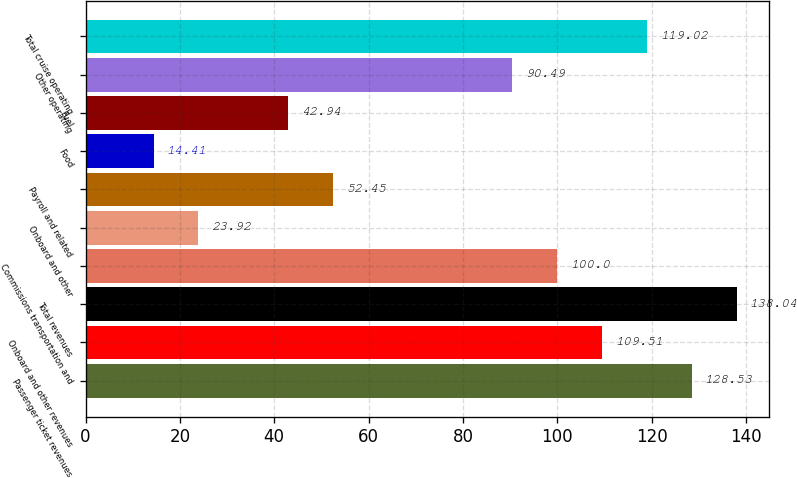<chart> <loc_0><loc_0><loc_500><loc_500><bar_chart><fcel>Passenger ticket revenues<fcel>Onboard and other revenues<fcel>Total revenues<fcel>Commissions transportation and<fcel>Onboard and other<fcel>Payroll and related<fcel>Food<fcel>Fuel<fcel>Other operating<fcel>Total cruise operating<nl><fcel>128.53<fcel>109.51<fcel>138.04<fcel>100<fcel>23.92<fcel>52.45<fcel>14.41<fcel>42.94<fcel>90.49<fcel>119.02<nl></chart> 